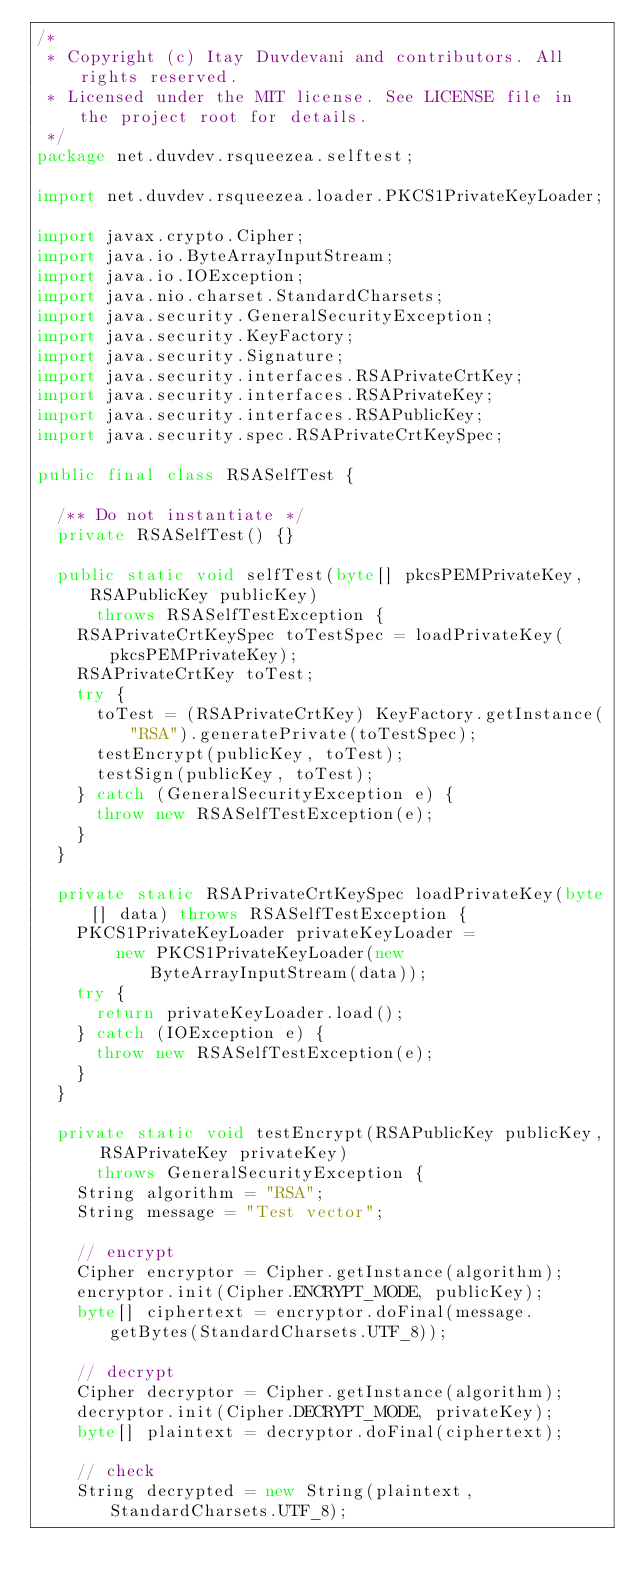Convert code to text. <code><loc_0><loc_0><loc_500><loc_500><_Java_>/*
 * Copyright (c) Itay Duvdevani and contributors. All rights reserved.
 * Licensed under the MIT license. See LICENSE file in the project root for details.
 */
package net.duvdev.rsqueezea.selftest;

import net.duvdev.rsqueezea.loader.PKCS1PrivateKeyLoader;

import javax.crypto.Cipher;
import java.io.ByteArrayInputStream;
import java.io.IOException;
import java.nio.charset.StandardCharsets;
import java.security.GeneralSecurityException;
import java.security.KeyFactory;
import java.security.Signature;
import java.security.interfaces.RSAPrivateCrtKey;
import java.security.interfaces.RSAPrivateKey;
import java.security.interfaces.RSAPublicKey;
import java.security.spec.RSAPrivateCrtKeySpec;

public final class RSASelfTest {

  /** Do not instantiate */
  private RSASelfTest() {}

  public static void selfTest(byte[] pkcsPEMPrivateKey, RSAPublicKey publicKey)
      throws RSASelfTestException {
    RSAPrivateCrtKeySpec toTestSpec = loadPrivateKey(pkcsPEMPrivateKey);
    RSAPrivateCrtKey toTest;
    try {
      toTest = (RSAPrivateCrtKey) KeyFactory.getInstance("RSA").generatePrivate(toTestSpec);
      testEncrypt(publicKey, toTest);
      testSign(publicKey, toTest);
    } catch (GeneralSecurityException e) {
      throw new RSASelfTestException(e);
    }
  }

  private static RSAPrivateCrtKeySpec loadPrivateKey(byte[] data) throws RSASelfTestException {
    PKCS1PrivateKeyLoader privateKeyLoader =
        new PKCS1PrivateKeyLoader(new ByteArrayInputStream(data));
    try {
      return privateKeyLoader.load();
    } catch (IOException e) {
      throw new RSASelfTestException(e);
    }
  }

  private static void testEncrypt(RSAPublicKey publicKey, RSAPrivateKey privateKey)
      throws GeneralSecurityException {
    String algorithm = "RSA";
    String message = "Test vector";

    // encrypt
    Cipher encryptor = Cipher.getInstance(algorithm);
    encryptor.init(Cipher.ENCRYPT_MODE, publicKey);
    byte[] ciphertext = encryptor.doFinal(message.getBytes(StandardCharsets.UTF_8));

    // decrypt
    Cipher decryptor = Cipher.getInstance(algorithm);
    decryptor.init(Cipher.DECRYPT_MODE, privateKey);
    byte[] plaintext = decryptor.doFinal(ciphertext);

    // check
    String decrypted = new String(plaintext, StandardCharsets.UTF_8);</code> 